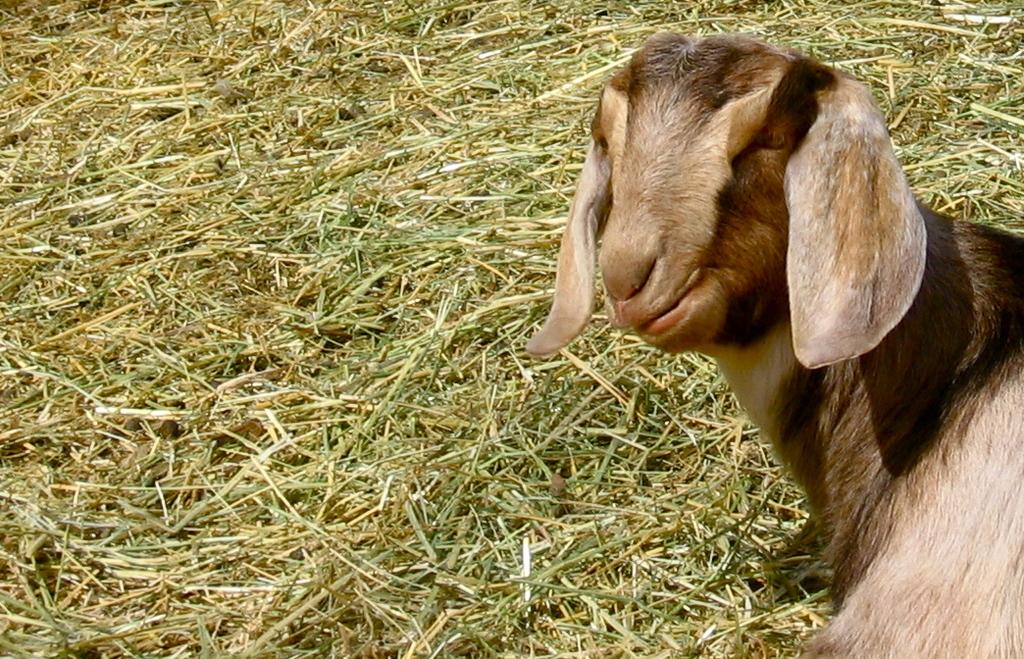What animal is present in the image? There is a goat in the image. What is the color of the goat? The goat is pale brown in color. What position is the goat in? The goat is sitting on the ground. What type of surface is the goat sitting on? The ground is covered with grass. What type of payment is the goat expecting in the image? There is no indication in the image that the goat is expecting any payment. 